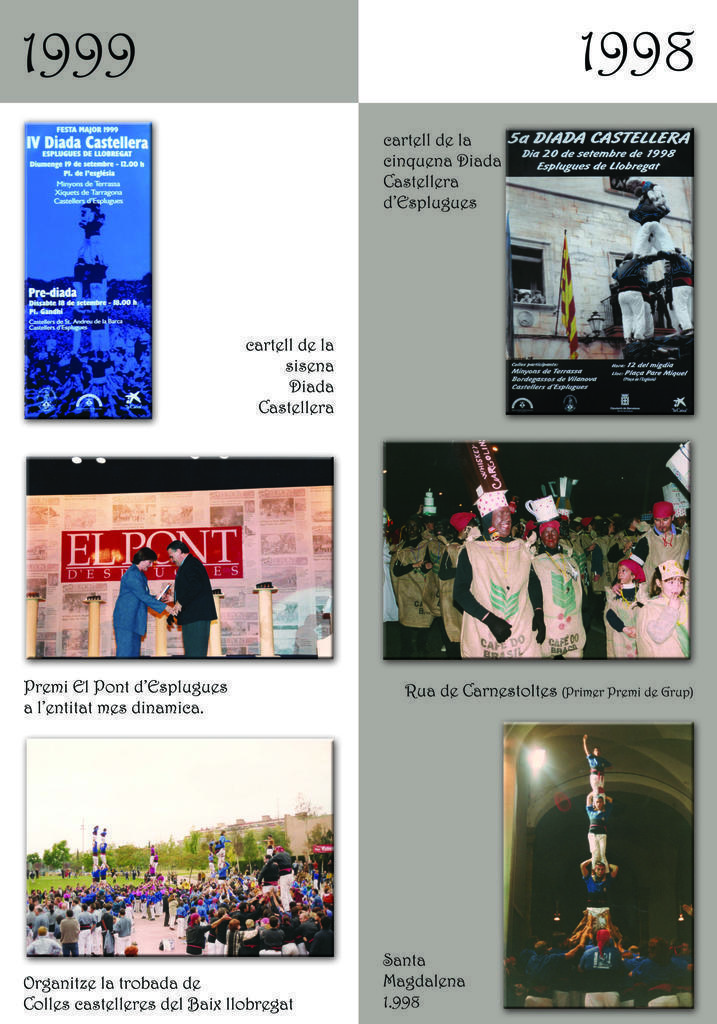Describe this image in one or two sentences. In this image there are different types of posters, on the posters we could see some persons and some text. 